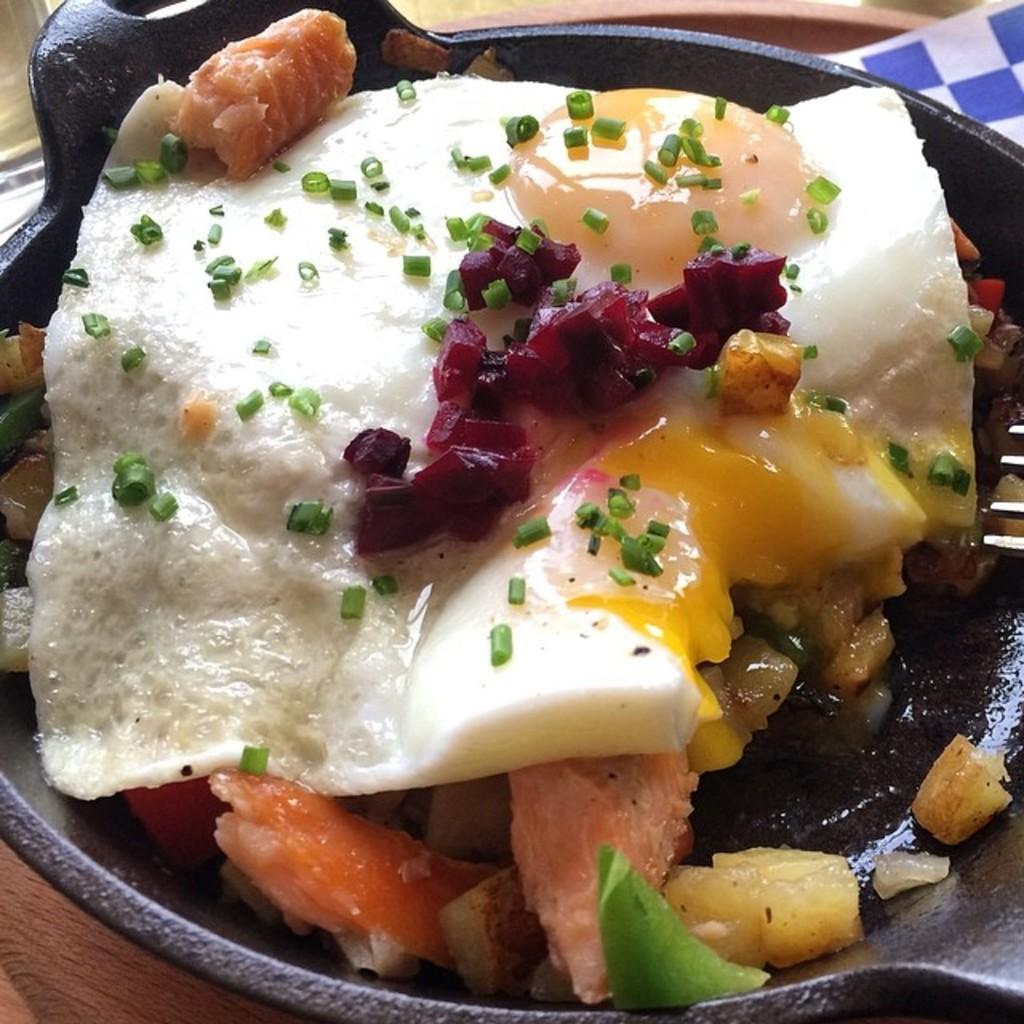What is the main object in the image? There is a container in the image. What is inside the container? The container holds a food item. What is the material of the surface beneath the container? The surface beneath the container appears to be made of wood. Are there any plants growing on the wooden surface in the image? There is no mention of plants in the image, so we cannot determine if there are any growing on the wooden surface. 